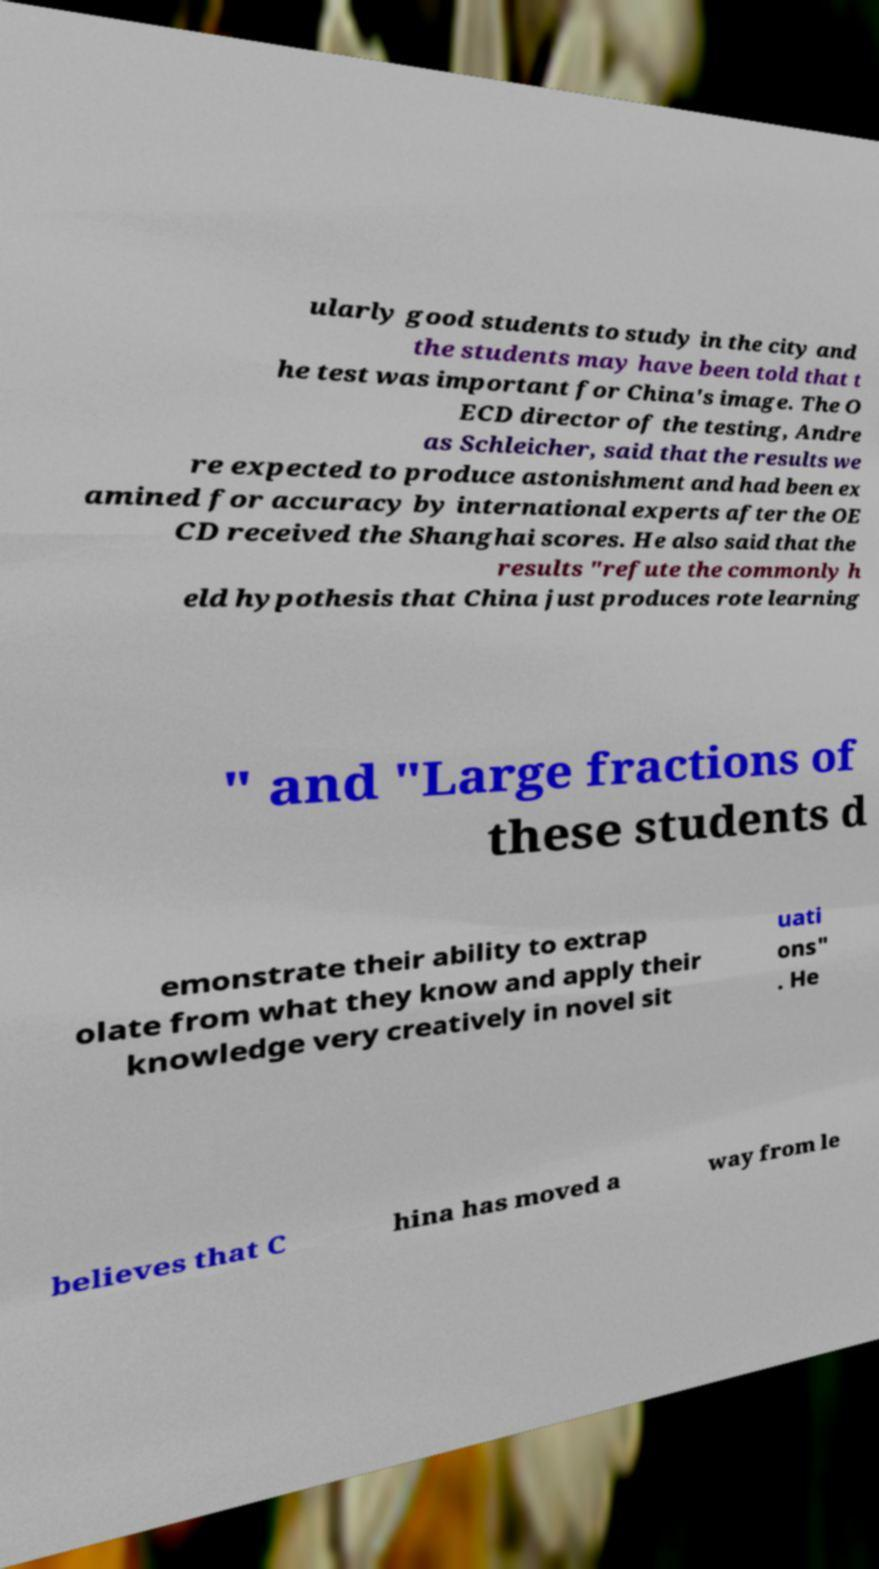I need the written content from this picture converted into text. Can you do that? ularly good students to study in the city and the students may have been told that t he test was important for China's image. The O ECD director of the testing, Andre as Schleicher, said that the results we re expected to produce astonishment and had been ex amined for accuracy by international experts after the OE CD received the Shanghai scores. He also said that the results "refute the commonly h eld hypothesis that China just produces rote learning " and "Large fractions of these students d emonstrate their ability to extrap olate from what they know and apply their knowledge very creatively in novel sit uati ons" . He believes that C hina has moved a way from le 